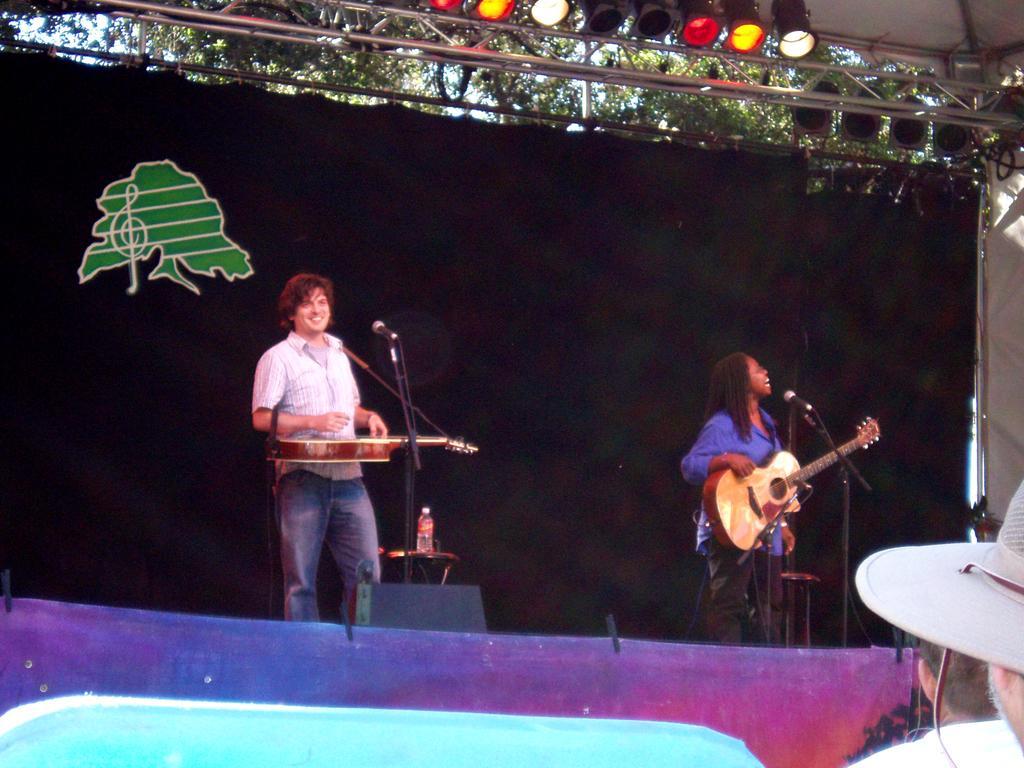Can you describe this image briefly? In this image i can see two persons who are playing guitar in front of them there are microphones who are standing on the stage and at the top of the image there are some lights. 